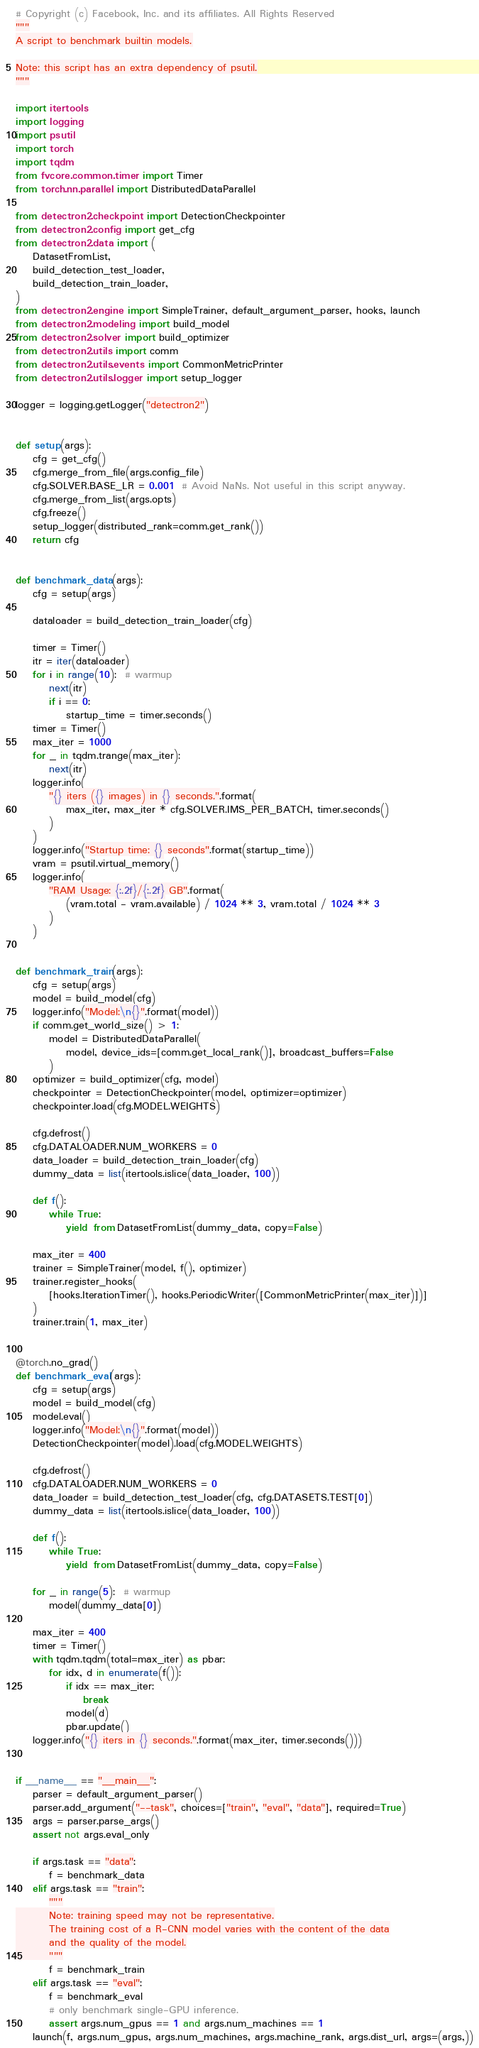Convert code to text. <code><loc_0><loc_0><loc_500><loc_500><_Python_># Copyright (c) Facebook, Inc. and its affiliates. All Rights Reserved
"""
A script to benchmark builtin models.

Note: this script has an extra dependency of psutil.
"""

import itertools
import logging
import psutil
import torch
import tqdm
from fvcore.common.timer import Timer
from torch.nn.parallel import DistributedDataParallel

from detectron2.checkpoint import DetectionCheckpointer
from detectron2.config import get_cfg
from detectron2.data import (
    DatasetFromList,
    build_detection_test_loader,
    build_detection_train_loader,
)
from detectron2.engine import SimpleTrainer, default_argument_parser, hooks, launch
from detectron2.modeling import build_model
from detectron2.solver import build_optimizer
from detectron2.utils import comm
from detectron2.utils.events import CommonMetricPrinter
from detectron2.utils.logger import setup_logger

logger = logging.getLogger("detectron2")


def setup(args):
    cfg = get_cfg()
    cfg.merge_from_file(args.config_file)
    cfg.SOLVER.BASE_LR = 0.001  # Avoid NaNs. Not useful in this script anyway.
    cfg.merge_from_list(args.opts)
    cfg.freeze()
    setup_logger(distributed_rank=comm.get_rank())
    return cfg


def benchmark_data(args):
    cfg = setup(args)

    dataloader = build_detection_train_loader(cfg)

    timer = Timer()
    itr = iter(dataloader)
    for i in range(10):  # warmup
        next(itr)
        if i == 0:
            startup_time = timer.seconds()
    timer = Timer()
    max_iter = 1000
    for _ in tqdm.trange(max_iter):
        next(itr)
    logger.info(
        "{} iters ({} images) in {} seconds.".format(
            max_iter, max_iter * cfg.SOLVER.IMS_PER_BATCH, timer.seconds()
        )
    )
    logger.info("Startup time: {} seconds".format(startup_time))
    vram = psutil.virtual_memory()
    logger.info(
        "RAM Usage: {:.2f}/{:.2f} GB".format(
            (vram.total - vram.available) / 1024 ** 3, vram.total / 1024 ** 3
        )
    )


def benchmark_train(args):
    cfg = setup(args)
    model = build_model(cfg)
    logger.info("Model:\n{}".format(model))
    if comm.get_world_size() > 1:
        model = DistributedDataParallel(
            model, device_ids=[comm.get_local_rank()], broadcast_buffers=False
        )
    optimizer = build_optimizer(cfg, model)
    checkpointer = DetectionCheckpointer(model, optimizer=optimizer)
    checkpointer.load(cfg.MODEL.WEIGHTS)

    cfg.defrost()
    cfg.DATALOADER.NUM_WORKERS = 0
    data_loader = build_detection_train_loader(cfg)
    dummy_data = list(itertools.islice(data_loader, 100))

    def f():
        while True:
            yield from DatasetFromList(dummy_data, copy=False)

    max_iter = 400
    trainer = SimpleTrainer(model, f(), optimizer)
    trainer.register_hooks(
        [hooks.IterationTimer(), hooks.PeriodicWriter([CommonMetricPrinter(max_iter)])]
    )
    trainer.train(1, max_iter)


@torch.no_grad()
def benchmark_eval(args):
    cfg = setup(args)
    model = build_model(cfg)
    model.eval()
    logger.info("Model:\n{}".format(model))
    DetectionCheckpointer(model).load(cfg.MODEL.WEIGHTS)

    cfg.defrost()
    cfg.DATALOADER.NUM_WORKERS = 0
    data_loader = build_detection_test_loader(cfg, cfg.DATASETS.TEST[0])
    dummy_data = list(itertools.islice(data_loader, 100))

    def f():
        while True:
            yield from DatasetFromList(dummy_data, copy=False)

    for _ in range(5):  # warmup
        model(dummy_data[0])

    max_iter = 400
    timer = Timer()
    with tqdm.tqdm(total=max_iter) as pbar:
        for idx, d in enumerate(f()):
            if idx == max_iter:
                break
            model(d)
            pbar.update()
    logger.info("{} iters in {} seconds.".format(max_iter, timer.seconds()))


if __name__ == "__main__":
    parser = default_argument_parser()
    parser.add_argument("--task", choices=["train", "eval", "data"], required=True)
    args = parser.parse_args()
    assert not args.eval_only

    if args.task == "data":
        f = benchmark_data
    elif args.task == "train":
        """
        Note: training speed may not be representative.
        The training cost of a R-CNN model varies with the content of the data
        and the quality of the model.
        """
        f = benchmark_train
    elif args.task == "eval":
        f = benchmark_eval
        # only benchmark single-GPU inference.
        assert args.num_gpus == 1 and args.num_machines == 1
    launch(f, args.num_gpus, args.num_machines, args.machine_rank, args.dist_url, args=(args,))
</code> 